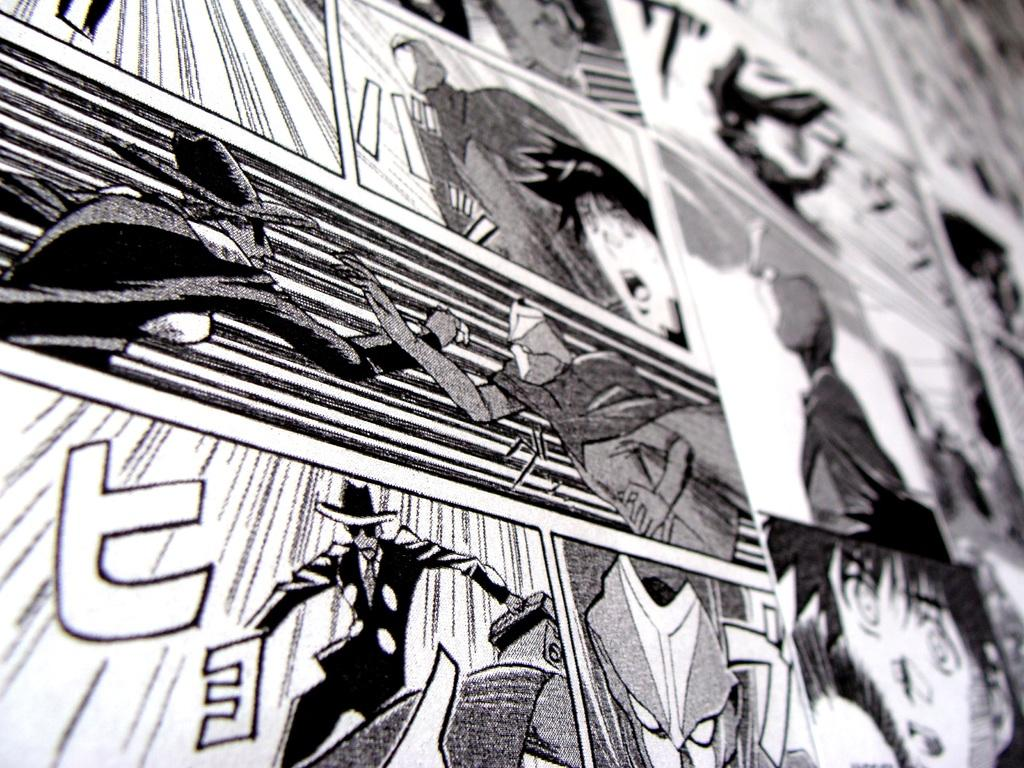What is the color scheme of the image? The image is black and white. What type of content is featured in the image? The image contains an animation. How many flowers are present in the image? There are no flowers present in the image, as it is an animation and not a photograph or illustration of a real-life scene. 